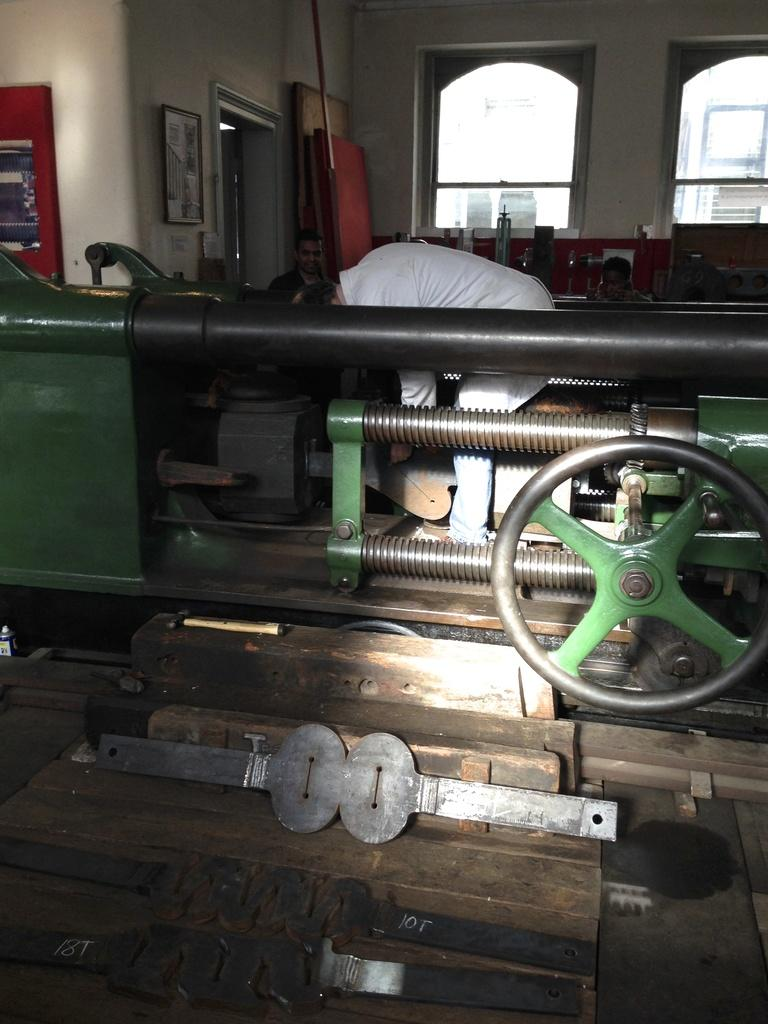Who is present in the image? There is a man in the image. What can be seen in the image besides the man? There is a machine, a wheel, and various objects in the image. What is visible on the wall in the background? There is a board and a frame on the wall in the background. What else can be seen in the background of the image? There are windows, people, and additional objects in the background. What type of beef is being cooked in the image? There is no beef or cooking activity present in the image. In which direction is the man facing in the image? The direction the man is facing cannot be determined from the image alone, as there is no reference point provided. 